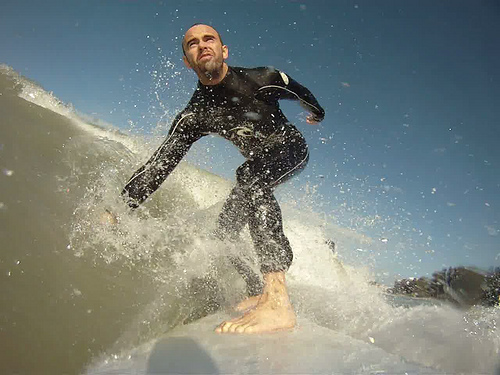Describe the physical and emotional elements portrayed in the image. The physical elements in this image are striking, with the surfer's agile body in sharp focus against the tumultuous, frothy wave. His wetsuit clings to his form, emphasizing the muscles and movement as he expertly navigates the surf. Emotionally, the image radiates feelings of exhilaration and concentration. The intensity in the surfer's eyes shows his focus and determination, while the dynamic motion of the wave suggests the thrill and unpredictability of the sport. What do you think the surfer is feeling at this moment? The surfer is likely experiencing a mix of adrenaline and exhilaration, common emotions felt during such intense and engaging activities. The sense of riding a powerful wave, feeling the ocean's force beneath him, likely brings about a profound connection to nature and a moment of pure thrill and freedom. Can you describe the surroundings in more detail? Are there any significant environmental features? This image captures not only the surfer and the wave but also hints at the broader environment. The sky is clear with a deep blue hue, suggesting a bright, sunny day ideal for surfing. The water appears to be relatively calm except for the rising wave the surfer is on, hinting at favorable ocean conditions. In the background, one can faintly discern some landmass or foliage, possibly indicating a coastal area. The combination of clear skies, dynamic waves, and distant land provides a beautiful backdrop to this thrilling surf scene. Imagine the surfer could tell us a story about this day. What story might he tell? The surfer might recount a tale of waking up before dawn, checking the surf reports, and feeling a surge of excitement at the ideal conditions. He would describe the crisp morning air and the anticipation as he paddled out into the vast ocean, feeling the cold spray of saltwater on his face. Each wave he rode was a new adventure, culminating in this particular moment captured in time. He might speak of the connection and harmony he felt with the ocean, each successful ride bringing an exhilarating sense of accomplishment. It was not just a day at the beach but a profound experience of nature, skill, and sheer joy. 